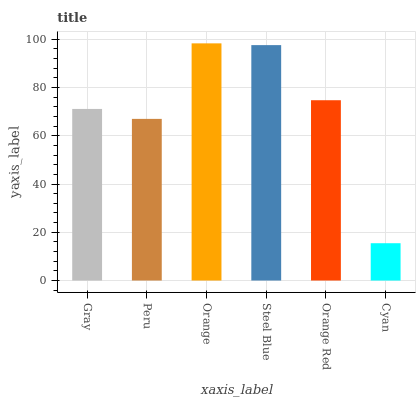Is Cyan the minimum?
Answer yes or no. Yes. Is Orange the maximum?
Answer yes or no. Yes. Is Peru the minimum?
Answer yes or no. No. Is Peru the maximum?
Answer yes or no. No. Is Gray greater than Peru?
Answer yes or no. Yes. Is Peru less than Gray?
Answer yes or no. Yes. Is Peru greater than Gray?
Answer yes or no. No. Is Gray less than Peru?
Answer yes or no. No. Is Orange Red the high median?
Answer yes or no. Yes. Is Gray the low median?
Answer yes or no. Yes. Is Gray the high median?
Answer yes or no. No. Is Orange the low median?
Answer yes or no. No. 